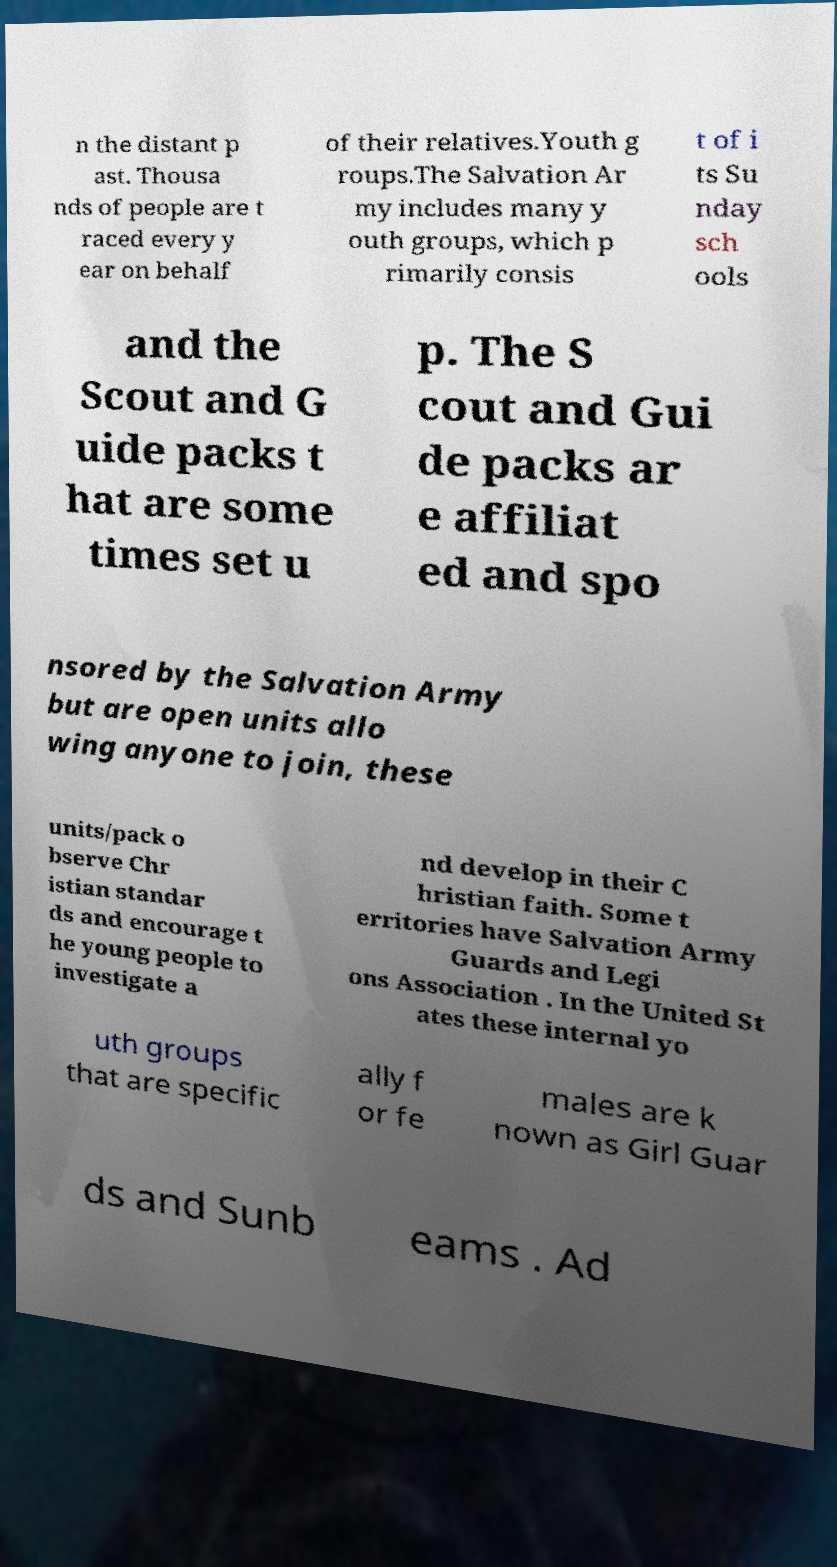Please identify and transcribe the text found in this image. n the distant p ast. Thousa nds of people are t raced every y ear on behalf of their relatives.Youth g roups.The Salvation Ar my includes many y outh groups, which p rimarily consis t of i ts Su nday sch ools and the Scout and G uide packs t hat are some times set u p. The S cout and Gui de packs ar e affiliat ed and spo nsored by the Salvation Army but are open units allo wing anyone to join, these units/pack o bserve Chr istian standar ds and encourage t he young people to investigate a nd develop in their C hristian faith. Some t erritories have Salvation Army Guards and Legi ons Association . In the United St ates these internal yo uth groups that are specific ally f or fe males are k nown as Girl Guar ds and Sunb eams . Ad 